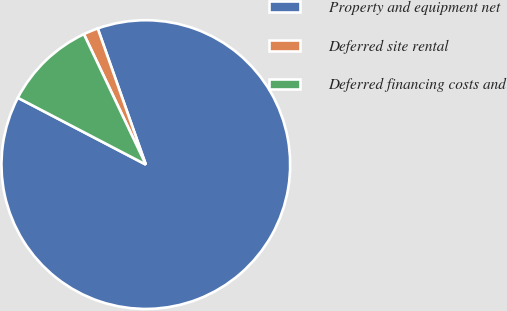Convert chart to OTSL. <chart><loc_0><loc_0><loc_500><loc_500><pie_chart><fcel>Property and equipment net<fcel>Deferred site rental<fcel>Deferred financing costs and<nl><fcel>88.07%<fcel>1.65%<fcel>10.29%<nl></chart> 